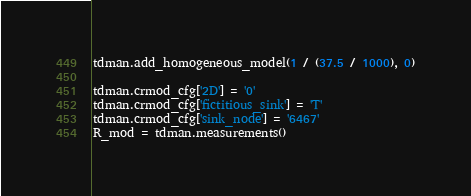Convert code to text. <code><loc_0><loc_0><loc_500><loc_500><_Python_>tdman.add_homogeneous_model(1 / (37.5 / 1000), 0)

tdman.crmod_cfg['2D'] = '0'
tdman.crmod_cfg['fictitious_sink'] = 'T'
tdman.crmod_cfg['sink_node'] = '6467'
R_mod = tdman.measurements()
</code> 